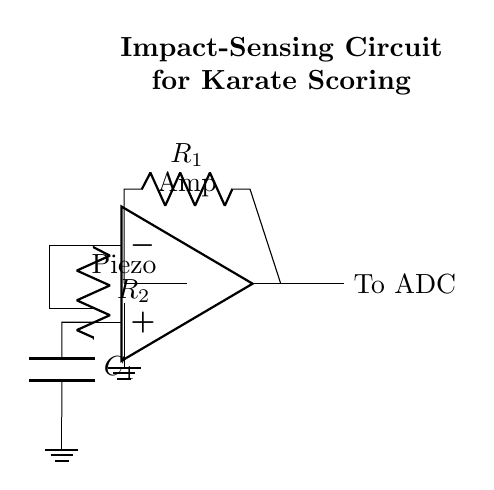What type of sensor is used in this circuit? The diagram shows a piezoelectric sensor, which is indicated by the specific symbol used for it. A piezoelectric sensor generates an electrical charge in response to mechanical stress, making it suitable for impact sensing.
Answer: Piezoelectric What do the resistors R1 and R2 do in this circuit? R1 is used to limit the current flowing into the amplifier from the piezoelectric sensor, ensuring safe operation, while R2 provides feedback within the operational amplifier to set the gain and stability of the circuit.
Answer: Current limiting and feedback How many components are connected directly to the amplifier? The amplifier is directly connected to two components: the piezoelectric sensor (via R1) for input and a resistor (R2) for feedback purposes.
Answer: Two What is the function of the capacitor C1 in this circuit? C1 in the circuit acts to smooth the output signal from the amplifier, filtering out high-frequency noise and providing a stable signal for the analog-to-digital converter (ADC).
Answer: Smoothing What is the output of the amplifier connected to? The output of the amplifier is connected to the analog-to-digital converter (ADC), which digitizes the signal for processing and scoring.
Answer: To ADC Why is grounding important in this circuit? Grounding is essential because it establishes a reference point for voltage levels in the circuit, ensuring stable operation and reducing noise, which is critical for accurate impact detection.
Answer: Stability and noise reduction 